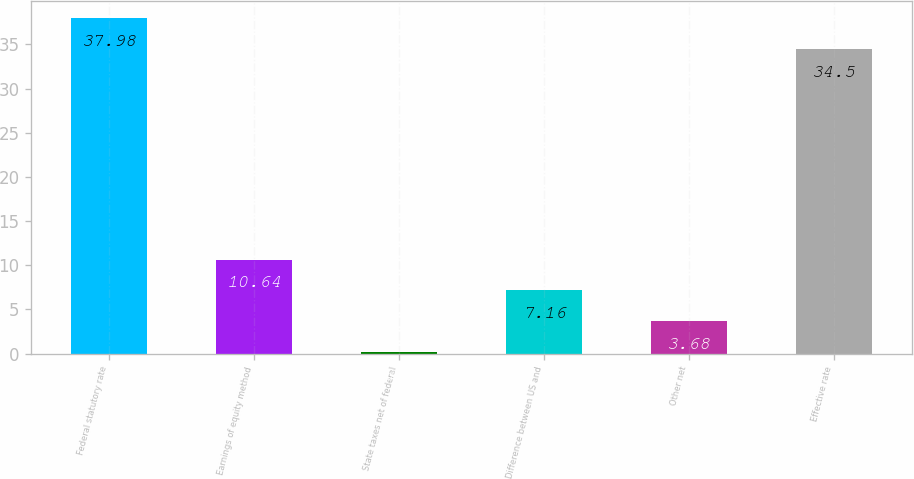Convert chart. <chart><loc_0><loc_0><loc_500><loc_500><bar_chart><fcel>Federal statutory rate<fcel>Earnings of equity method<fcel>State taxes net of federal<fcel>Difference between US and<fcel>Other net<fcel>Effective rate<nl><fcel>37.98<fcel>10.64<fcel>0.2<fcel>7.16<fcel>3.68<fcel>34.5<nl></chart> 